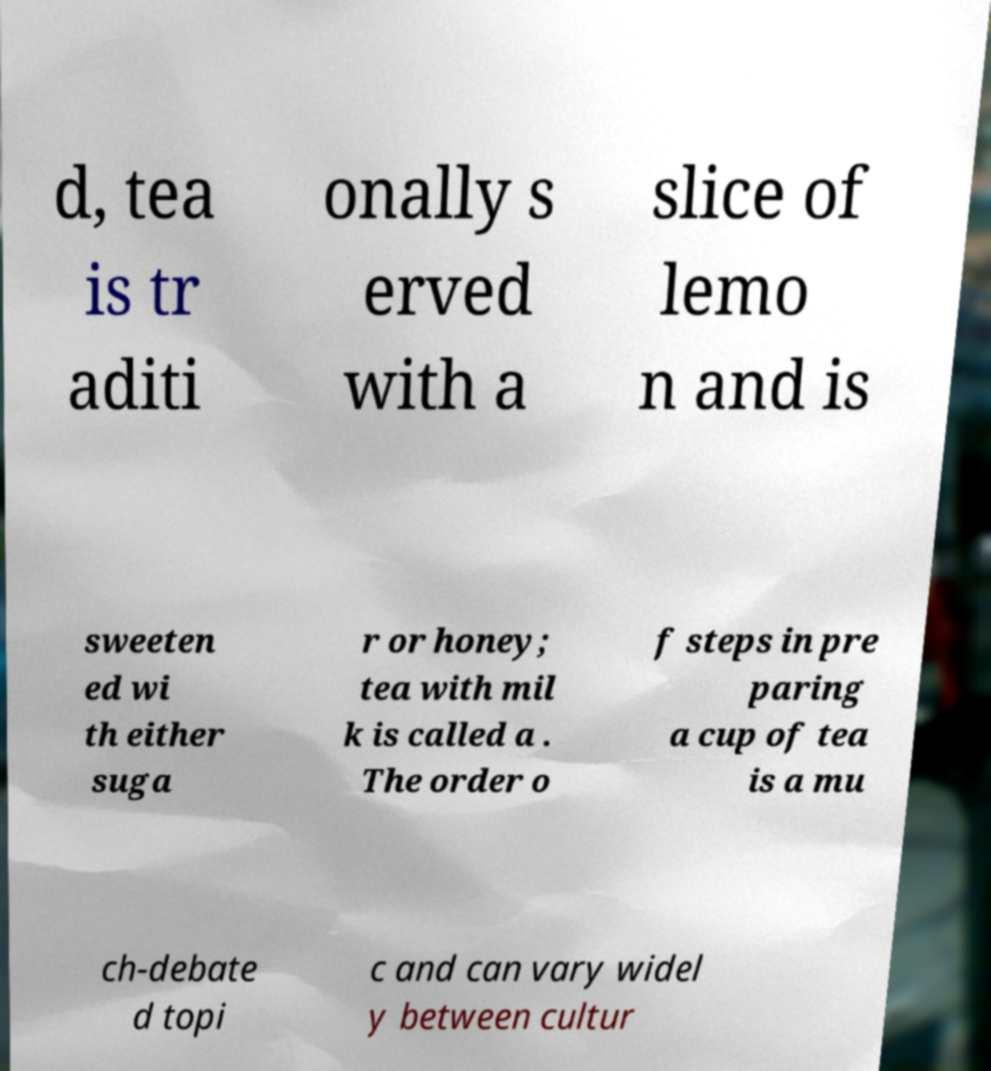For documentation purposes, I need the text within this image transcribed. Could you provide that? d, tea is tr aditi onally s erved with a slice of lemo n and is sweeten ed wi th either suga r or honey; tea with mil k is called a . The order o f steps in pre paring a cup of tea is a mu ch-debate d topi c and can vary widel y between cultur 